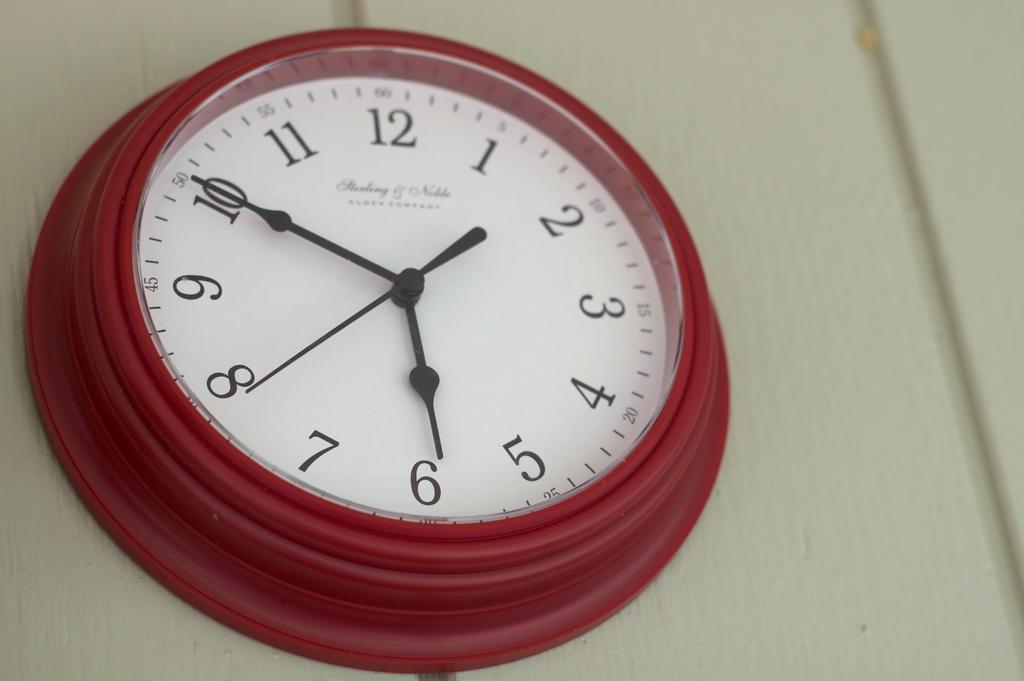How would you summarize this image in a sentence or two? In this image we can see a clock attached to the wall. 